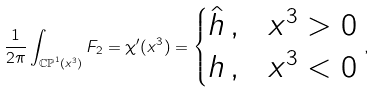<formula> <loc_0><loc_0><loc_500><loc_500>\frac { 1 } { 2 \pi } \int _ { \mathbb { C P } ^ { 1 } ( x ^ { 3 } ) } F _ { 2 } = \chi ^ { \prime } ( x ^ { 3 } ) = \begin{cases} \hat { h } \, , & x ^ { 3 } > 0 \\ h \, , & x ^ { 3 } < 0 \end{cases} \, ,</formula> 